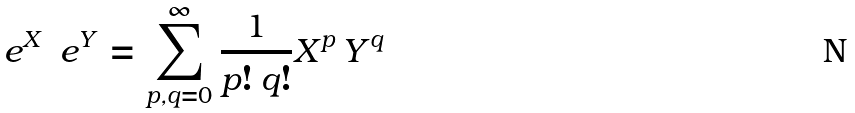<formula> <loc_0><loc_0><loc_500><loc_500>\ e ^ { X } \, \ e ^ { Y } = \sum _ { p , q = 0 } ^ { \infty } \frac { 1 } { p ! \, q ! } X ^ { p } \, Y ^ { q }</formula> 